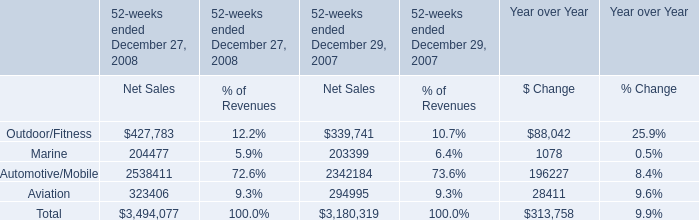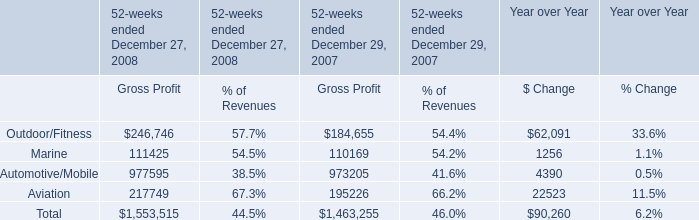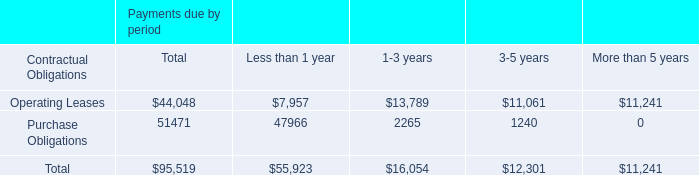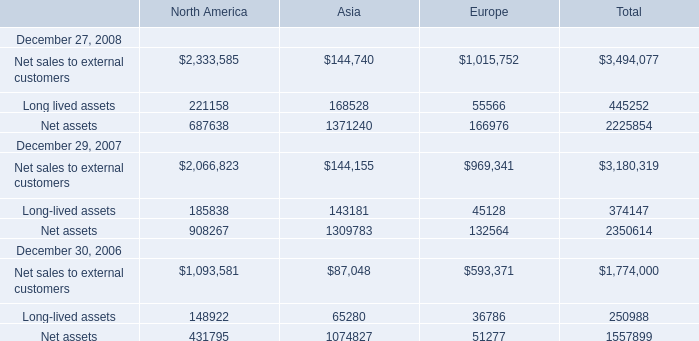In the year with largest amount of Net assets , what's the sum of Asia? 
Computations: ((144155 + 1309783) + 143181)
Answer: 1597119.0. 